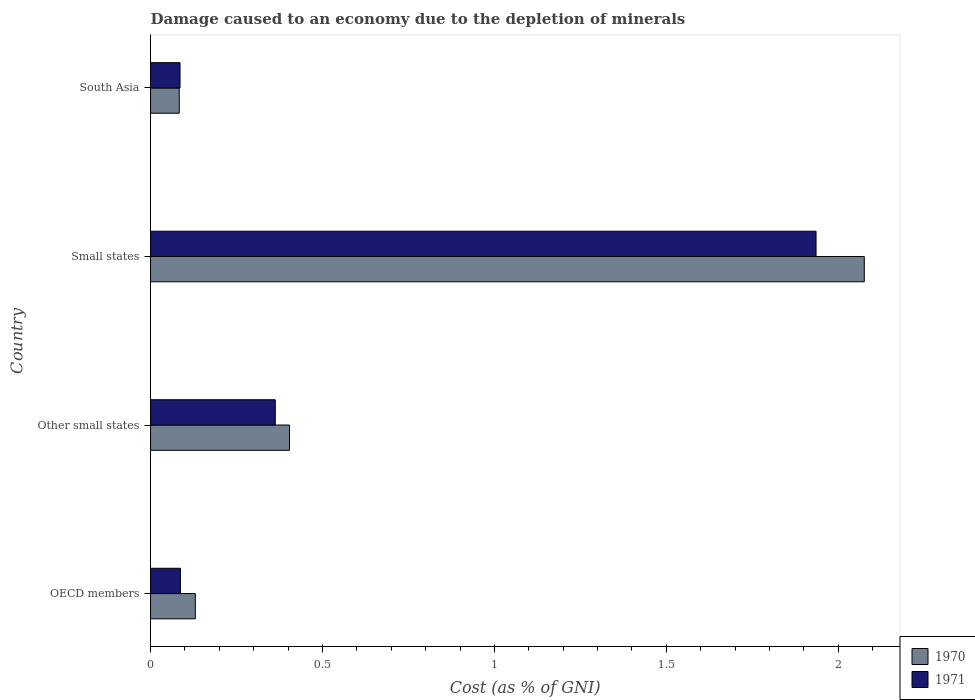How many different coloured bars are there?
Make the answer very short. 2. How many bars are there on the 1st tick from the top?
Provide a succinct answer. 2. What is the label of the 3rd group of bars from the top?
Make the answer very short. Other small states. In how many cases, is the number of bars for a given country not equal to the number of legend labels?
Your answer should be compact. 0. What is the cost of damage caused due to the depletion of minerals in 1970 in Other small states?
Provide a succinct answer. 0.4. Across all countries, what is the maximum cost of damage caused due to the depletion of minerals in 1971?
Provide a succinct answer. 1.94. Across all countries, what is the minimum cost of damage caused due to the depletion of minerals in 1971?
Provide a short and direct response. 0.09. In which country was the cost of damage caused due to the depletion of minerals in 1971 maximum?
Your answer should be very brief. Small states. In which country was the cost of damage caused due to the depletion of minerals in 1971 minimum?
Offer a terse response. South Asia. What is the total cost of damage caused due to the depletion of minerals in 1970 in the graph?
Keep it short and to the point. 2.69. What is the difference between the cost of damage caused due to the depletion of minerals in 1971 in Small states and that in South Asia?
Ensure brevity in your answer.  1.85. What is the difference between the cost of damage caused due to the depletion of minerals in 1970 in South Asia and the cost of damage caused due to the depletion of minerals in 1971 in Small states?
Ensure brevity in your answer.  -1.85. What is the average cost of damage caused due to the depletion of minerals in 1970 per country?
Make the answer very short. 0.67. What is the difference between the cost of damage caused due to the depletion of minerals in 1971 and cost of damage caused due to the depletion of minerals in 1970 in South Asia?
Your response must be concise. 0. In how many countries, is the cost of damage caused due to the depletion of minerals in 1970 greater than 0.30000000000000004 %?
Offer a very short reply. 2. What is the ratio of the cost of damage caused due to the depletion of minerals in 1971 in OECD members to that in Small states?
Provide a succinct answer. 0.04. Is the cost of damage caused due to the depletion of minerals in 1971 in OECD members less than that in Small states?
Ensure brevity in your answer.  Yes. Is the difference between the cost of damage caused due to the depletion of minerals in 1971 in Small states and South Asia greater than the difference between the cost of damage caused due to the depletion of minerals in 1970 in Small states and South Asia?
Offer a very short reply. No. What is the difference between the highest and the second highest cost of damage caused due to the depletion of minerals in 1970?
Your answer should be compact. 1.67. What is the difference between the highest and the lowest cost of damage caused due to the depletion of minerals in 1971?
Make the answer very short. 1.85. Is the sum of the cost of damage caused due to the depletion of minerals in 1971 in Small states and South Asia greater than the maximum cost of damage caused due to the depletion of minerals in 1970 across all countries?
Offer a very short reply. No. What does the 2nd bar from the top in Small states represents?
Offer a terse response. 1970. What does the 2nd bar from the bottom in Other small states represents?
Your answer should be very brief. 1971. How many bars are there?
Offer a terse response. 8. Are all the bars in the graph horizontal?
Keep it short and to the point. Yes. How many countries are there in the graph?
Provide a short and direct response. 4. What is the difference between two consecutive major ticks on the X-axis?
Keep it short and to the point. 0.5. Where does the legend appear in the graph?
Keep it short and to the point. Bottom right. How many legend labels are there?
Your response must be concise. 2. How are the legend labels stacked?
Your response must be concise. Vertical. What is the title of the graph?
Give a very brief answer. Damage caused to an economy due to the depletion of minerals. What is the label or title of the X-axis?
Your response must be concise. Cost (as % of GNI). What is the label or title of the Y-axis?
Your response must be concise. Country. What is the Cost (as % of GNI) of 1970 in OECD members?
Provide a short and direct response. 0.13. What is the Cost (as % of GNI) in 1971 in OECD members?
Your answer should be very brief. 0.09. What is the Cost (as % of GNI) of 1970 in Other small states?
Offer a very short reply. 0.4. What is the Cost (as % of GNI) of 1971 in Other small states?
Provide a short and direct response. 0.36. What is the Cost (as % of GNI) of 1970 in Small states?
Offer a terse response. 2.08. What is the Cost (as % of GNI) in 1971 in Small states?
Offer a terse response. 1.94. What is the Cost (as % of GNI) in 1970 in South Asia?
Ensure brevity in your answer.  0.08. What is the Cost (as % of GNI) of 1971 in South Asia?
Your response must be concise. 0.09. Across all countries, what is the maximum Cost (as % of GNI) in 1970?
Your answer should be very brief. 2.08. Across all countries, what is the maximum Cost (as % of GNI) in 1971?
Keep it short and to the point. 1.94. Across all countries, what is the minimum Cost (as % of GNI) in 1970?
Your response must be concise. 0.08. Across all countries, what is the minimum Cost (as % of GNI) in 1971?
Offer a very short reply. 0.09. What is the total Cost (as % of GNI) of 1970 in the graph?
Provide a succinct answer. 2.69. What is the total Cost (as % of GNI) in 1971 in the graph?
Make the answer very short. 2.47. What is the difference between the Cost (as % of GNI) of 1970 in OECD members and that in Other small states?
Provide a short and direct response. -0.27. What is the difference between the Cost (as % of GNI) in 1971 in OECD members and that in Other small states?
Your response must be concise. -0.28. What is the difference between the Cost (as % of GNI) in 1970 in OECD members and that in Small states?
Keep it short and to the point. -1.95. What is the difference between the Cost (as % of GNI) in 1971 in OECD members and that in Small states?
Offer a very short reply. -1.85. What is the difference between the Cost (as % of GNI) in 1970 in OECD members and that in South Asia?
Your answer should be compact. 0.05. What is the difference between the Cost (as % of GNI) of 1971 in OECD members and that in South Asia?
Your response must be concise. 0. What is the difference between the Cost (as % of GNI) in 1970 in Other small states and that in Small states?
Offer a very short reply. -1.67. What is the difference between the Cost (as % of GNI) of 1971 in Other small states and that in Small states?
Offer a very short reply. -1.57. What is the difference between the Cost (as % of GNI) in 1970 in Other small states and that in South Asia?
Offer a very short reply. 0.32. What is the difference between the Cost (as % of GNI) of 1971 in Other small states and that in South Asia?
Make the answer very short. 0.28. What is the difference between the Cost (as % of GNI) in 1970 in Small states and that in South Asia?
Your answer should be compact. 1.99. What is the difference between the Cost (as % of GNI) of 1971 in Small states and that in South Asia?
Offer a very short reply. 1.85. What is the difference between the Cost (as % of GNI) of 1970 in OECD members and the Cost (as % of GNI) of 1971 in Other small states?
Your response must be concise. -0.23. What is the difference between the Cost (as % of GNI) of 1970 in OECD members and the Cost (as % of GNI) of 1971 in Small states?
Offer a terse response. -1.81. What is the difference between the Cost (as % of GNI) in 1970 in OECD members and the Cost (as % of GNI) in 1971 in South Asia?
Keep it short and to the point. 0.04. What is the difference between the Cost (as % of GNI) in 1970 in Other small states and the Cost (as % of GNI) in 1971 in Small states?
Provide a succinct answer. -1.53. What is the difference between the Cost (as % of GNI) of 1970 in Other small states and the Cost (as % of GNI) of 1971 in South Asia?
Offer a very short reply. 0.32. What is the difference between the Cost (as % of GNI) in 1970 in Small states and the Cost (as % of GNI) in 1971 in South Asia?
Give a very brief answer. 1.99. What is the average Cost (as % of GNI) in 1970 per country?
Your answer should be very brief. 0.67. What is the average Cost (as % of GNI) of 1971 per country?
Give a very brief answer. 0.62. What is the difference between the Cost (as % of GNI) in 1970 and Cost (as % of GNI) in 1971 in OECD members?
Make the answer very short. 0.04. What is the difference between the Cost (as % of GNI) in 1970 and Cost (as % of GNI) in 1971 in Other small states?
Your response must be concise. 0.04. What is the difference between the Cost (as % of GNI) of 1970 and Cost (as % of GNI) of 1971 in Small states?
Offer a very short reply. 0.14. What is the difference between the Cost (as % of GNI) of 1970 and Cost (as % of GNI) of 1971 in South Asia?
Your answer should be very brief. -0. What is the ratio of the Cost (as % of GNI) of 1970 in OECD members to that in Other small states?
Keep it short and to the point. 0.32. What is the ratio of the Cost (as % of GNI) in 1971 in OECD members to that in Other small states?
Give a very brief answer. 0.24. What is the ratio of the Cost (as % of GNI) of 1970 in OECD members to that in Small states?
Provide a succinct answer. 0.06. What is the ratio of the Cost (as % of GNI) of 1971 in OECD members to that in Small states?
Offer a terse response. 0.04. What is the ratio of the Cost (as % of GNI) in 1970 in OECD members to that in South Asia?
Offer a very short reply. 1.56. What is the ratio of the Cost (as % of GNI) in 1971 in OECD members to that in South Asia?
Ensure brevity in your answer.  1.01. What is the ratio of the Cost (as % of GNI) of 1970 in Other small states to that in Small states?
Ensure brevity in your answer.  0.19. What is the ratio of the Cost (as % of GNI) of 1971 in Other small states to that in Small states?
Offer a very short reply. 0.19. What is the ratio of the Cost (as % of GNI) of 1970 in Other small states to that in South Asia?
Provide a succinct answer. 4.84. What is the ratio of the Cost (as % of GNI) of 1971 in Other small states to that in South Asia?
Your answer should be very brief. 4.23. What is the ratio of the Cost (as % of GNI) in 1970 in Small states to that in South Asia?
Your response must be concise. 24.88. What is the ratio of the Cost (as % of GNI) of 1971 in Small states to that in South Asia?
Keep it short and to the point. 22.57. What is the difference between the highest and the second highest Cost (as % of GNI) of 1970?
Ensure brevity in your answer.  1.67. What is the difference between the highest and the second highest Cost (as % of GNI) in 1971?
Offer a terse response. 1.57. What is the difference between the highest and the lowest Cost (as % of GNI) of 1970?
Give a very brief answer. 1.99. What is the difference between the highest and the lowest Cost (as % of GNI) in 1971?
Provide a succinct answer. 1.85. 